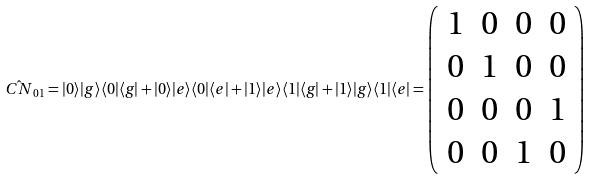Convert formula to latex. <formula><loc_0><loc_0><loc_500><loc_500>\hat { C N } _ { 0 1 } = | 0 \rangle | g \rangle \langle 0 | \langle g | + | 0 \rangle | e \rangle \langle 0 | \langle e | + | 1 \rangle | e \rangle \langle 1 | \langle g | + | 1 \rangle | g \rangle \langle 1 | \langle e | = \left ( \begin{array} { c c c c } 1 & 0 & 0 & 0 \\ 0 & 1 & 0 & 0 \\ 0 & 0 & 0 & 1 \\ 0 & 0 & 1 & 0 \end{array} \right )</formula> 